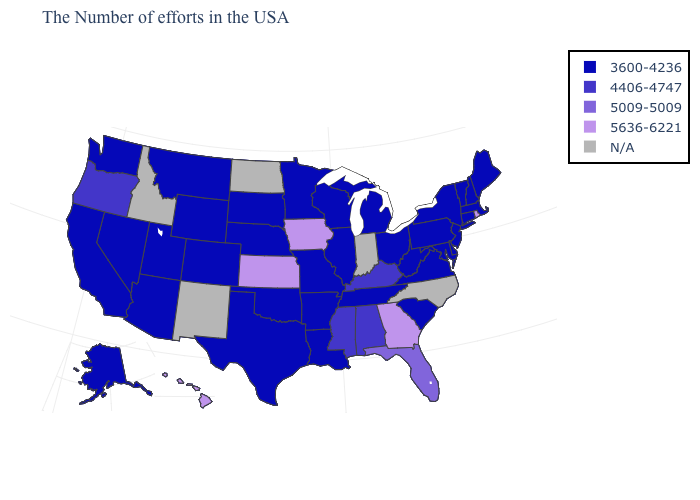How many symbols are there in the legend?
Short answer required. 5. Which states hav the highest value in the MidWest?
Answer briefly. Iowa, Kansas. Name the states that have a value in the range 4406-4747?
Concise answer only. Kentucky, Alabama, Mississippi, Oregon. How many symbols are there in the legend?
Write a very short answer. 5. What is the value of Alabama?
Give a very brief answer. 4406-4747. Name the states that have a value in the range 5636-6221?
Answer briefly. Rhode Island, Georgia, Iowa, Kansas, Hawaii. Name the states that have a value in the range N/A?
Answer briefly. North Carolina, Indiana, North Dakota, New Mexico, Idaho. What is the value of New Mexico?
Keep it brief. N/A. Name the states that have a value in the range N/A?
Keep it brief. North Carolina, Indiana, North Dakota, New Mexico, Idaho. How many symbols are there in the legend?
Give a very brief answer. 5. What is the value of North Dakota?
Be succinct. N/A. Name the states that have a value in the range 5636-6221?
Write a very short answer. Rhode Island, Georgia, Iowa, Kansas, Hawaii. What is the lowest value in the MidWest?
Write a very short answer. 3600-4236. 